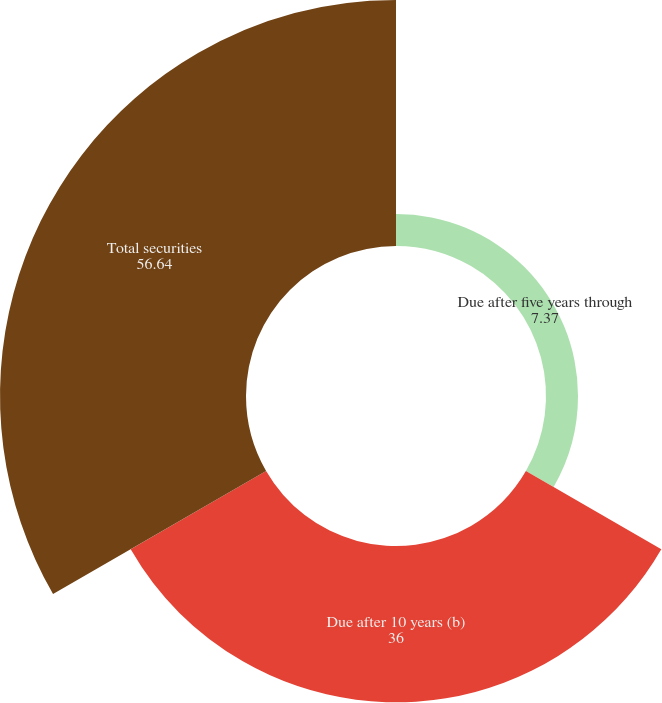Convert chart. <chart><loc_0><loc_0><loc_500><loc_500><pie_chart><fcel>Due after five years through<fcel>Due after 10 years (b)<fcel>Total securities<nl><fcel>7.37%<fcel>36.0%<fcel>56.64%<nl></chart> 